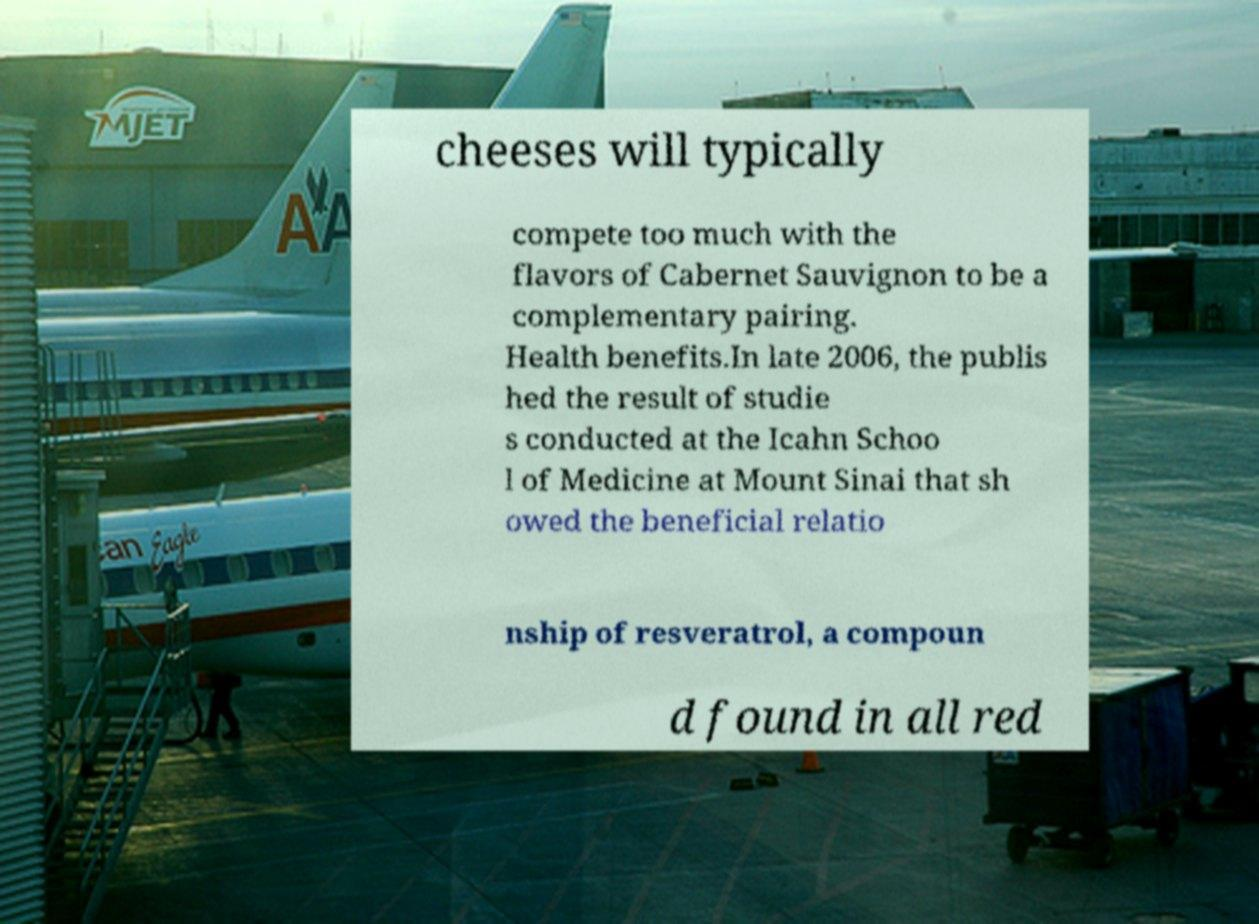What messages or text are displayed in this image? I need them in a readable, typed format. cheeses will typically compete too much with the flavors of Cabernet Sauvignon to be a complementary pairing. Health benefits.In late 2006, the publis hed the result of studie s conducted at the Icahn Schoo l of Medicine at Mount Sinai that sh owed the beneficial relatio nship of resveratrol, a compoun d found in all red 